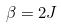Convert formula to latex. <formula><loc_0><loc_0><loc_500><loc_500>\beta = 2 J</formula> 